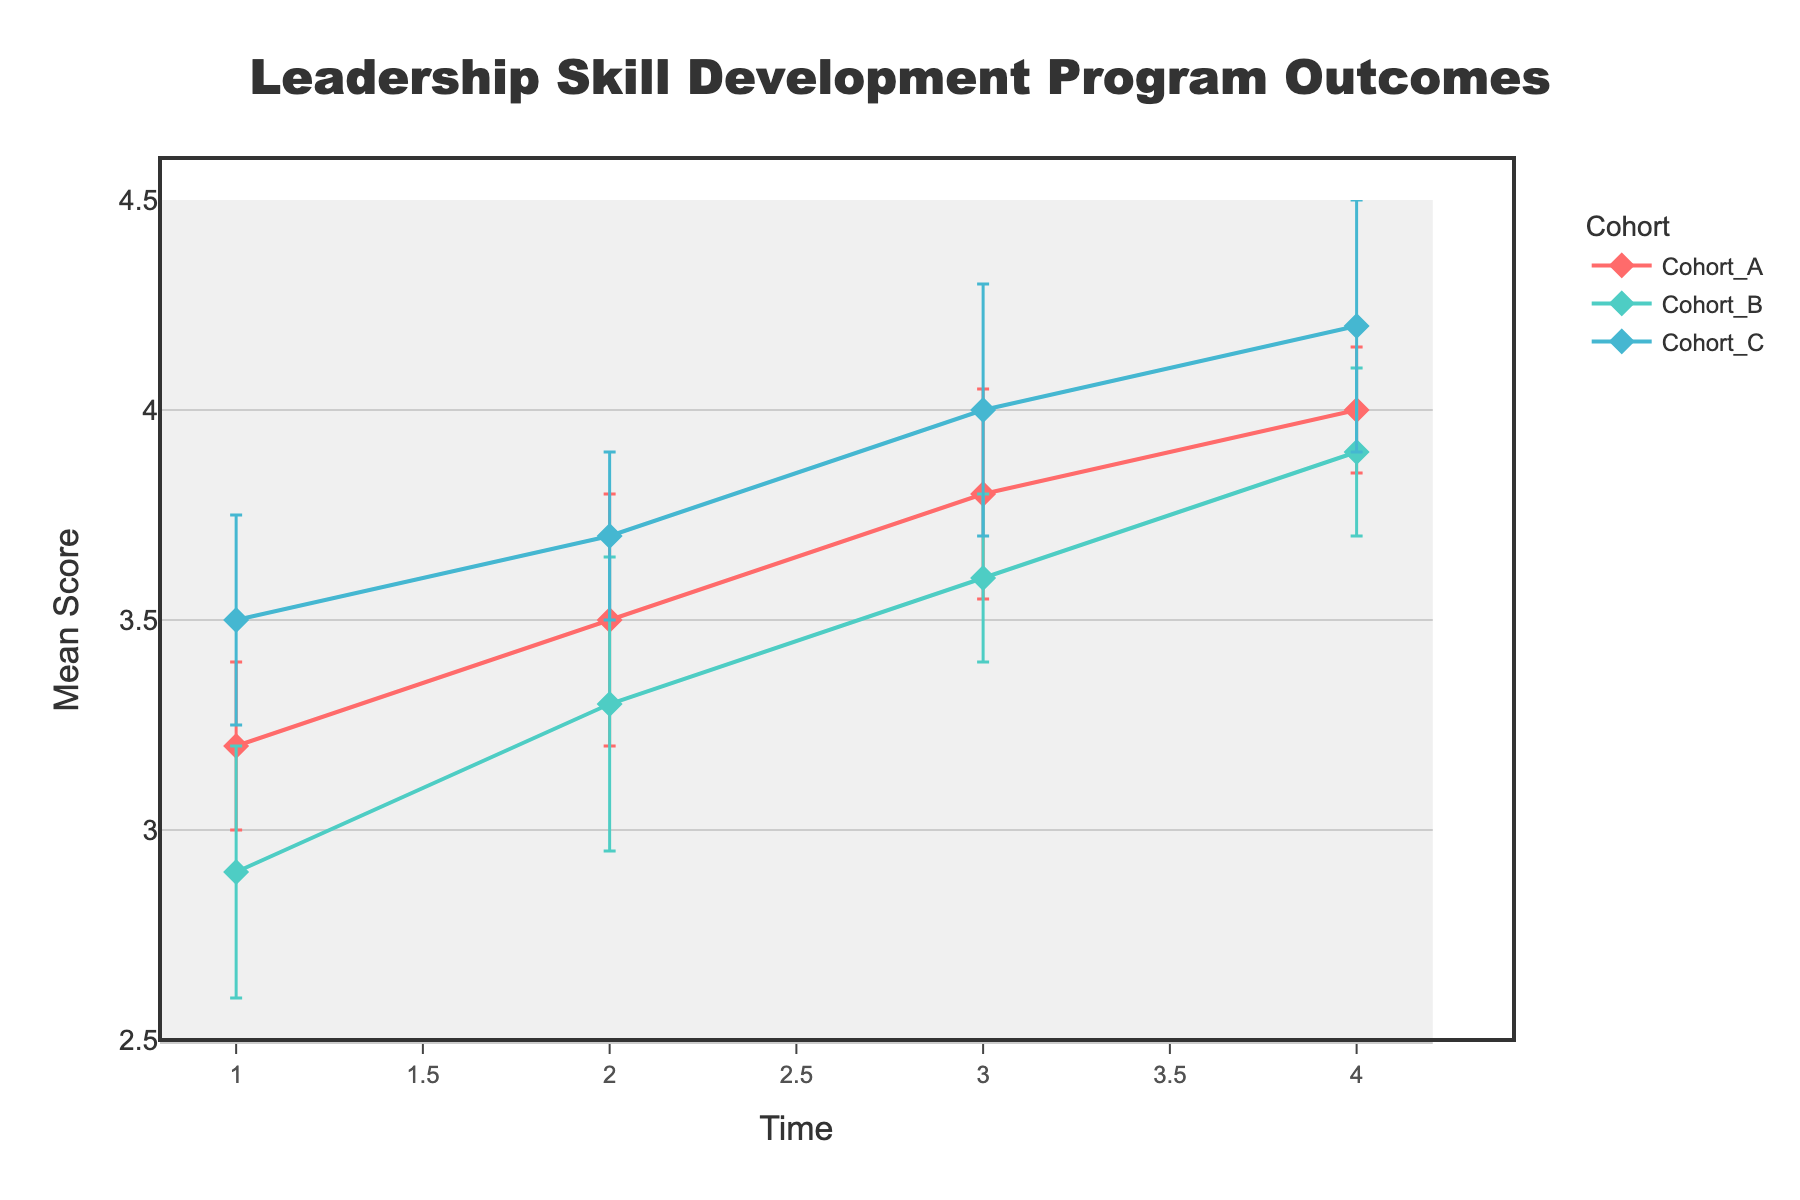What is the title of the figure? The title of the figure is typically shown at the top center of the plot. In this figure, the title reads "Leadership Skill Development Program Outcomes".
Answer: Leadership Skill Development Program Outcomes How many cohorts are represented in this figure? By looking at the legend in the figure, we can see the different cohorts listed. There are three cohorts: Cohort_A, Cohort_B, and Cohort_C.
Answer: Three What is the mean score for Cohort_B at Time 3? Locate the line for Cohort_B which is labeled in the legend. Then, find the data point at Time 3 on this line. The mean score at this point is 3.6.
Answer: 3.6 Which cohort shows the highest mean score at Time 1? By looking at the values on the y-axis at Time 1 for all three cohorts, we can see that Cohort_C has the highest mean score with a value of 3.5.
Answer: Cohort_C What is the range of mean scores for Cohort_A from Time 1 to Time 4? Find the mean scores for Cohort_A at Time 1 and Time 4. The values are 3.2 and 4.0 respectively. The range is calculated as 4.0 - 3.2.
Answer: 0.8 Which cohort had the highest increase in mean score from Time 1 to Time 4? Calculate the increase for each cohort: 
Cohort_A: 4.0 - 3.2 = 0.8,
Cohort_B: 3.9 - 2.9 = 1.0,
Cohort_C: 4.2 - 3.5 = 0.7. Cohort_B had the highest increase of 1.0.
Answer: Cohort_B What is the standard error for Cohort_A at Time 2? Find the standard error bar for Cohort_A at Time 2 by locating the error bars on the line for Cohort_A. The standard error is 0.3.
Answer: 0.3 Which cohort has the smallest standard error at Time 4? Look at the error bars corresponding to Time 4 for each cohort. Cohort_A has the smallest error bar at 0.15.
Answer: Cohort_A What is the average mean score for Cohort_C across all times? Calculate the average of the mean scores for Cohort_C: (3.5 + 3.7 + 4.0 + 4.2) / 4 = 3.85.
Answer: 3.85 